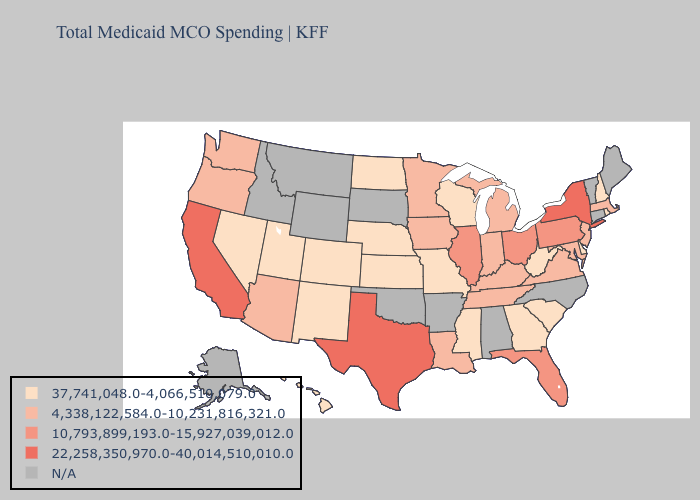What is the lowest value in states that border Arizona?
Give a very brief answer. 37,741,048.0-4,066,510,079.0. Does the map have missing data?
Quick response, please. Yes. What is the lowest value in the MidWest?
Be succinct. 37,741,048.0-4,066,510,079.0. What is the lowest value in the Northeast?
Quick response, please. 37,741,048.0-4,066,510,079.0. Does the map have missing data?
Give a very brief answer. Yes. What is the value of Washington?
Write a very short answer. 4,338,122,584.0-10,231,816,321.0. Name the states that have a value in the range 4,338,122,584.0-10,231,816,321.0?
Quick response, please. Arizona, Indiana, Iowa, Kentucky, Louisiana, Maryland, Massachusetts, Michigan, Minnesota, New Jersey, Oregon, Tennessee, Virginia, Washington. How many symbols are there in the legend?
Concise answer only. 5. What is the highest value in the South ?
Quick response, please. 22,258,350,970.0-40,014,510,010.0. What is the highest value in the West ?
Be succinct. 22,258,350,970.0-40,014,510,010.0. Among the states that border Indiana , does Michigan have the highest value?
Short answer required. No. Which states hav the highest value in the MidWest?
Short answer required. Illinois, Ohio. Name the states that have a value in the range N/A?
Answer briefly. Alabama, Alaska, Arkansas, Connecticut, Idaho, Maine, Montana, North Carolina, Oklahoma, South Dakota, Vermont, Wyoming. Among the states that border Virginia , does West Virginia have the lowest value?
Answer briefly. Yes. 